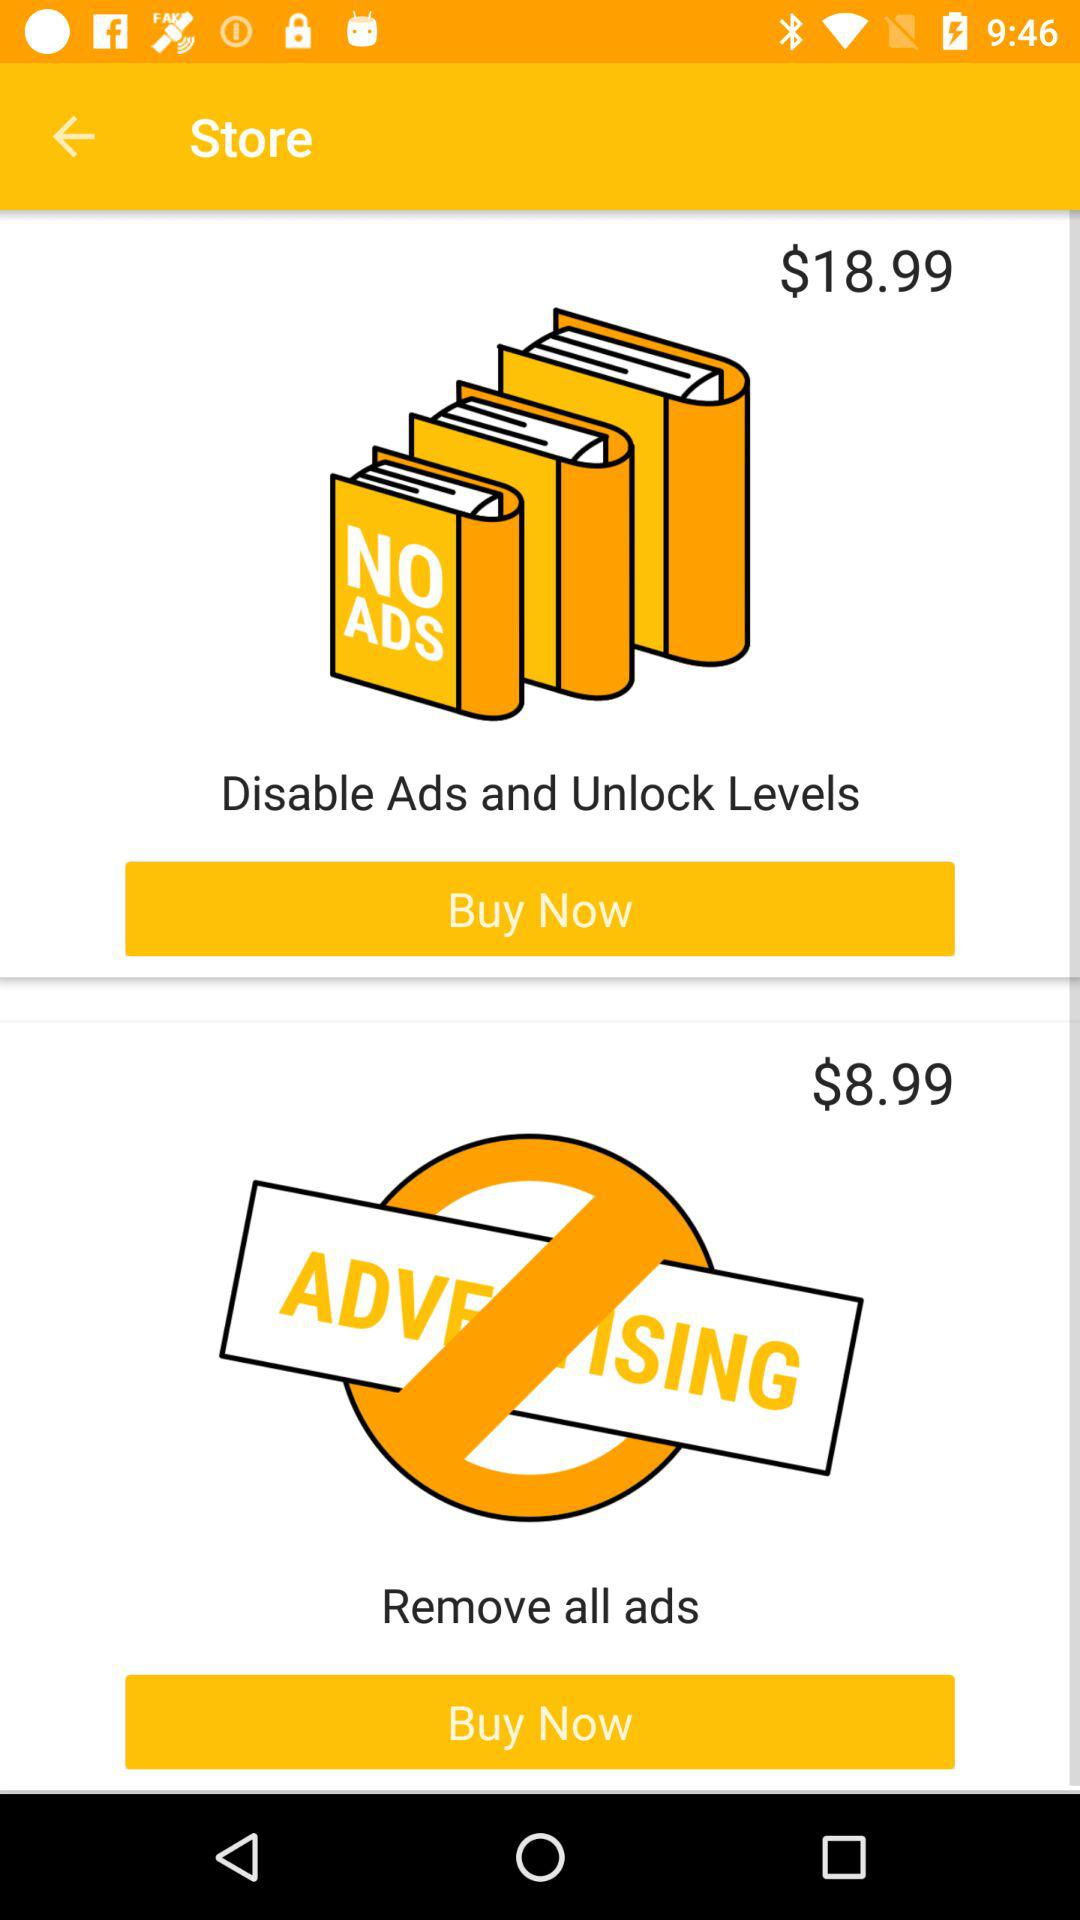What is the price of "Disable Ads and Unlock Levels"? The price is $18.99. 